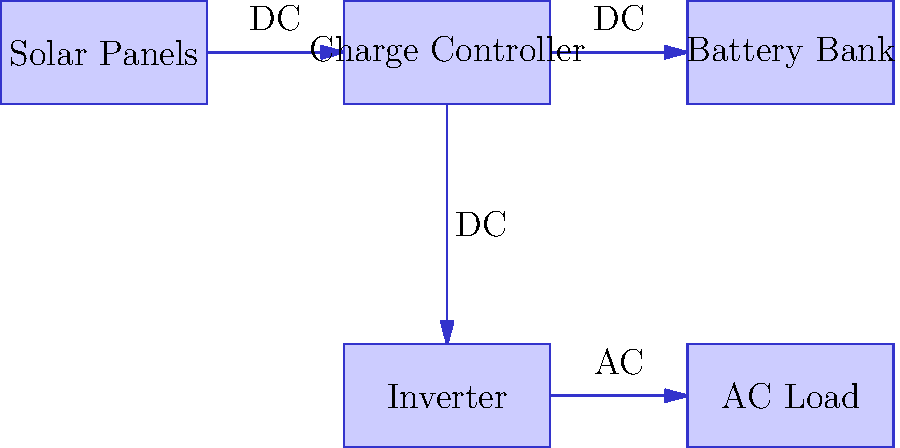As a small business owner of an insurance agency in Dublin, Ohio, you're considering installing a basic solar panel system for your office. Based on the block diagram provided, which component is responsible for converting DC power from the solar panels to AC power for use in the office equipment? Let's analyze the block diagram step-by-step to understand the flow of energy and the function of each component:

1. Solar Panels: These generate DC (Direct Current) electricity from sunlight.

2. Charge Controller: This regulates the voltage and current coming from the solar panels to safely charge the batteries.

3. Battery Bank: This stores the DC electricity generated by the solar panels for later use.

4. Inverter: This is the key component for answering the question. The inverter converts the DC electricity from either the solar panels or the battery bank into AC (Alternating Current) electricity, which is the type used by most office equipment.

5. AC Load: This represents the office equipment that uses the AC electricity.

The flow of electricity in the system is as follows:
- DC electricity flows from the Solar Panels to the Charge Controller
- DC electricity flows from the Charge Controller to the Battery Bank for storage
- DC electricity flows from either the Solar Panels or Battery Bank to the Inverter
- The Inverter converts DC to AC electricity
- AC electricity flows from the Inverter to the AC Load (office equipment)

Therefore, the component responsible for converting DC power to AC power is the Inverter.
Answer: Inverter 